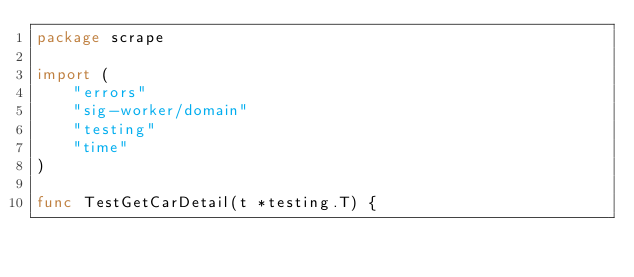Convert code to text. <code><loc_0><loc_0><loc_500><loc_500><_Go_>package scrape

import (
	"errors"
	"sig-worker/domain"
	"testing"
	"time"
)

func TestGetCarDetail(t *testing.T) {</code> 